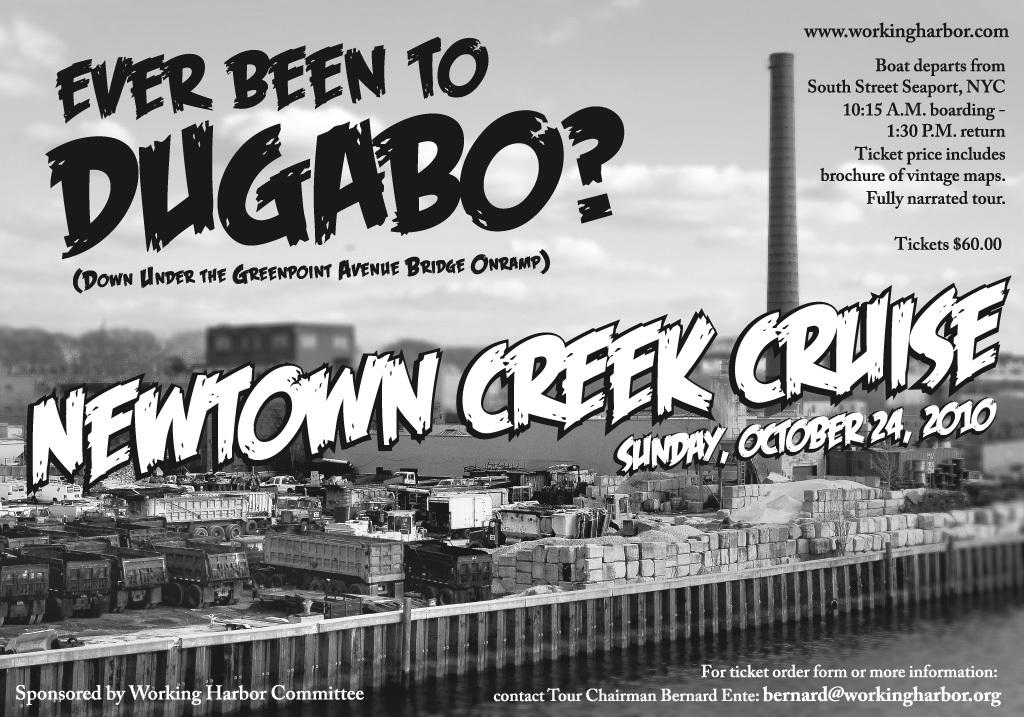Provide a one-sentence caption for the provided image. an advertisement from newtown creek cruise asking if the reader has been to dugabo. 